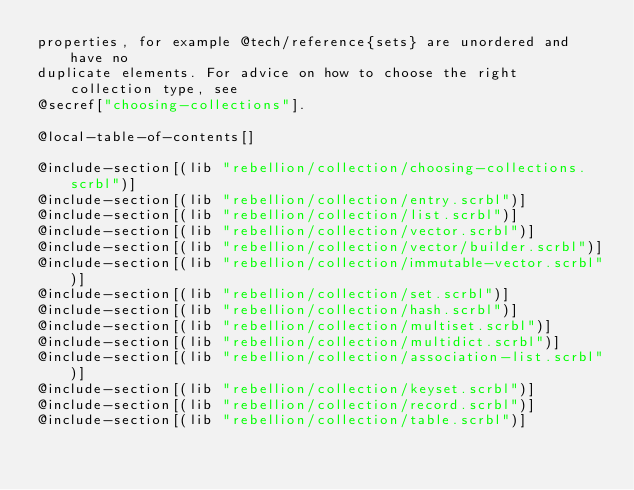<code> <loc_0><loc_0><loc_500><loc_500><_Racket_>properties, for example @tech/reference{sets} are unordered and have no
duplicate elements. For advice on how to choose the right collection type, see
@secref["choosing-collections"].

@local-table-of-contents[]

@include-section[(lib "rebellion/collection/choosing-collections.scrbl")]
@include-section[(lib "rebellion/collection/entry.scrbl")]
@include-section[(lib "rebellion/collection/list.scrbl")]
@include-section[(lib "rebellion/collection/vector.scrbl")]
@include-section[(lib "rebellion/collection/vector/builder.scrbl")]
@include-section[(lib "rebellion/collection/immutable-vector.scrbl")]
@include-section[(lib "rebellion/collection/set.scrbl")]
@include-section[(lib "rebellion/collection/hash.scrbl")]
@include-section[(lib "rebellion/collection/multiset.scrbl")]
@include-section[(lib "rebellion/collection/multidict.scrbl")]
@include-section[(lib "rebellion/collection/association-list.scrbl")]
@include-section[(lib "rebellion/collection/keyset.scrbl")]
@include-section[(lib "rebellion/collection/record.scrbl")]
@include-section[(lib "rebellion/collection/table.scrbl")]
</code> 